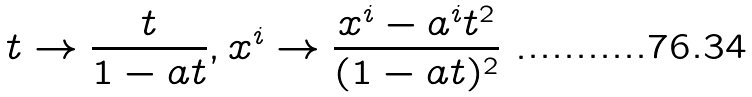<formula> <loc_0><loc_0><loc_500><loc_500>t \rightarrow \frac { t } { 1 - a t } , x ^ { i } \rightarrow \frac { x ^ { i } - a ^ { i } t ^ { 2 } } { ( 1 - a t ) ^ { 2 } } \ .</formula> 